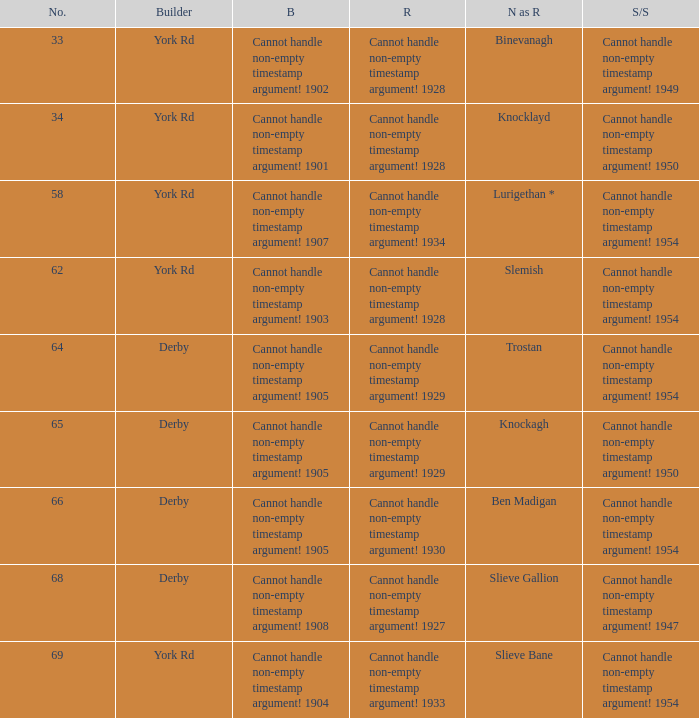Which Scrapped/Sold has a Name as rebuilt of trostan? Cannot handle non-empty timestamp argument! 1954. 